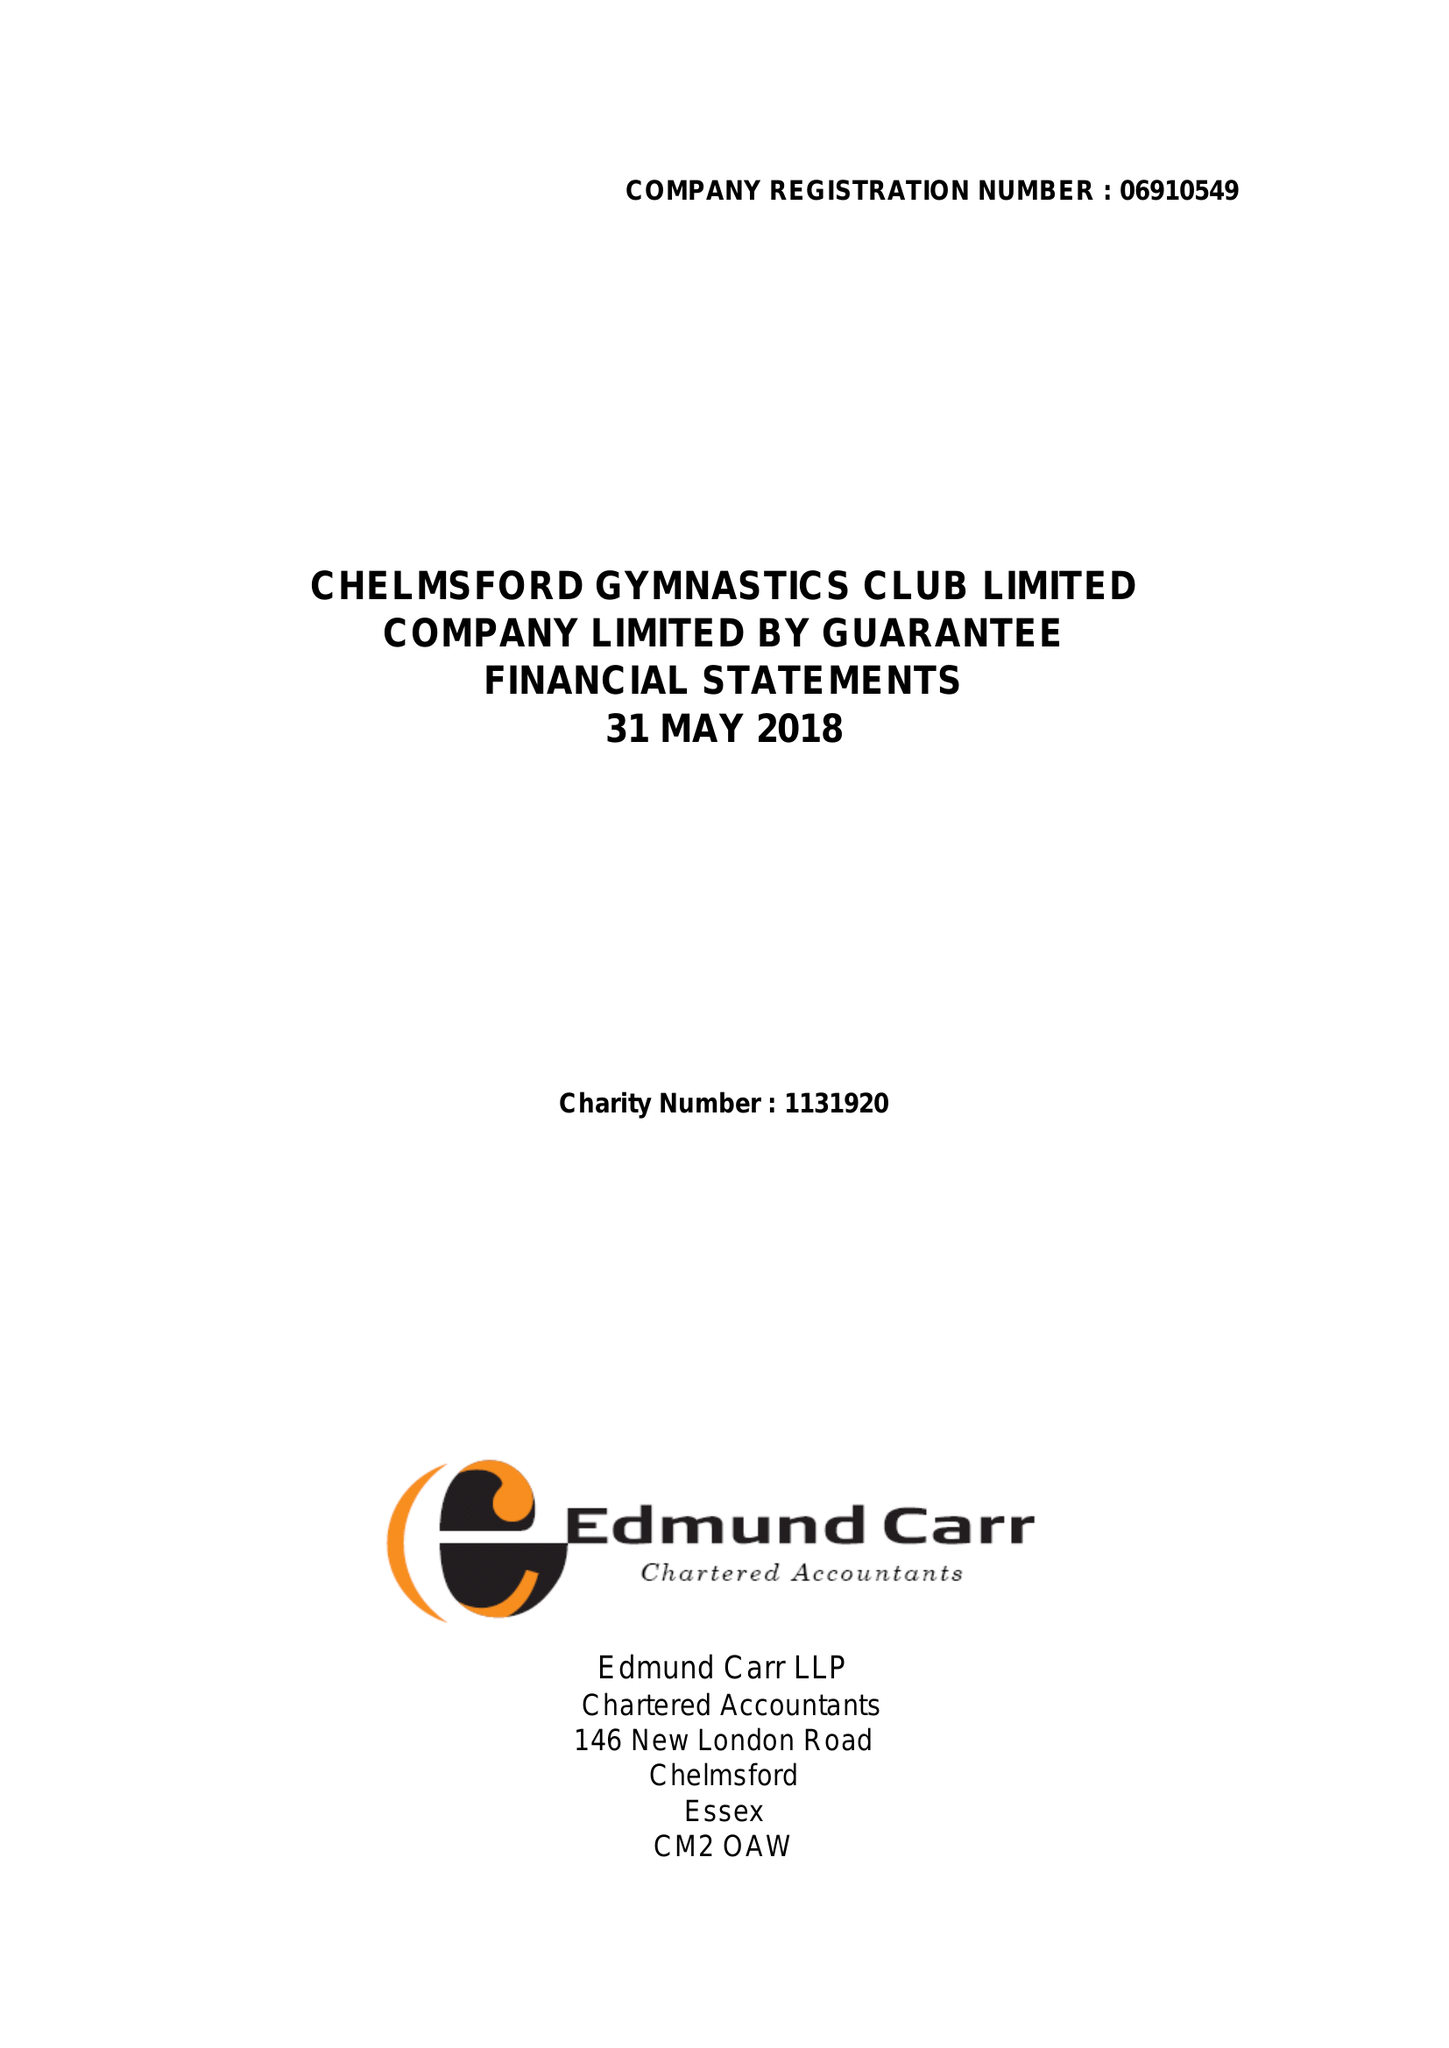What is the value for the spending_annually_in_british_pounds?
Answer the question using a single word or phrase. 447757.00 